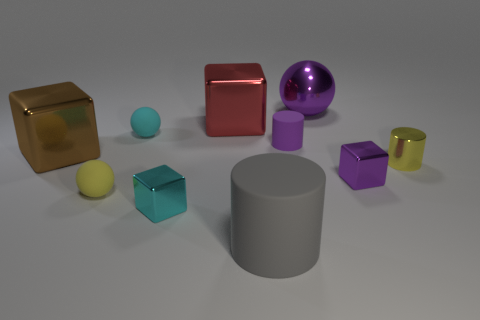Do the large metal ball and the small rubber cylinder have the same color?
Provide a succinct answer. Yes. There is a purple thing that is the same shape as the gray object; what is it made of?
Your answer should be compact. Rubber. How many things are either tiny yellow cylinders or small things in front of the brown cube?
Provide a succinct answer. 4. Does the tiny ball that is in front of the tiny purple shiny object have the same color as the metallic cylinder?
Give a very brief answer. Yes. The cylinder that is both to the left of the tiny purple metallic thing and behind the gray rubber thing is what color?
Your response must be concise. Purple. What is the small yellow thing that is left of the big matte thing made of?
Offer a terse response. Rubber. What size is the purple metallic block?
Your answer should be very brief. Small. What number of purple things are either big metallic blocks or tiny shiny things?
Your answer should be compact. 1. There is a purple shiny object to the left of the tiny shiny block that is right of the large purple metal object; how big is it?
Your response must be concise. Large. There is a tiny rubber cylinder; is its color the same as the small metallic cube to the right of the large gray cylinder?
Your response must be concise. Yes. 